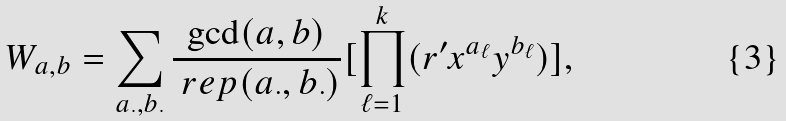<formula> <loc_0><loc_0><loc_500><loc_500>W _ { a , b } = \sum _ { a _ { \cdot } , b _ { \cdot } } \frac { \gcd ( a , b ) } { \ r e p ( a _ { \cdot } , b _ { \cdot } ) } [ \prod _ { \ell = 1 } ^ { k } ( r ^ { \prime } x ^ { a _ { \ell } } y ^ { b _ { \ell } } ) ] ,</formula> 